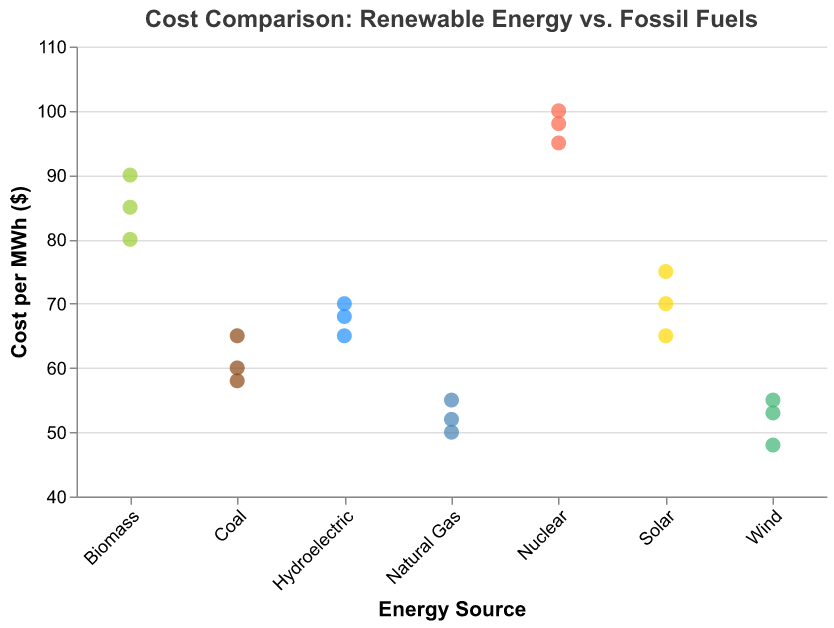What is the title of the figure? The title is displayed at the top of the figure and reads "Cost Comparison: Renewable Energy vs. Fossil Fuels."
Answer: Cost Comparison: Renewable Energy vs. Fossil Fuels Which energy source has the highest cost per MWh? By observing the data points, Nuclear has the highest costs that are around 95, 98, and 100 per MWh.
Answer: Nuclear What is the range of costs for Wind energy? The cost range for Wind energy can be determined from the minimum and maximum values of its data points. Wind energy costs are 48, 53, and 55 per MWh, so the range is from 48 to 55 per MWh.
Answer: 48 to 55 How do the costs of Natural Gas and Solar energy compare? By comparing the data points for Natural Gas (50, 52, 55) and Solar (65, 70, 75), it's clear that Solar energy generally has higher costs per MWh.
Answer: Solar has higher costs Are there any energy sources with overlapping cost ranges, and if so, which ones? To determine overlap, compare the cost ranges of all sources. Hydroelectric (65, 68, 70) and Solar (65, 70, 75) have overlapping ranges. Similarly, Natural Gas (50, 52, 55) and Wind (48, 53, 55) also overlap.
Answer: Hydroelectric and Solar, Natural Gas and Wind Which energy source has the least variation in cost per MWh? By examining the spread of data points, Natural Gas shows the least variation with costs of 50, 52, and 55 per MWh, indicating the smallest range and standard deviation.
Answer: Natural Gas What is the average cost per MWh of Solar energy? Sum the Solar energy costs (65 + 70 + 75) = 210, then divide by the number of points (3) to get the average: 210 / 3 = 70 per MWh.
Answer: 70 Which energy source has data points with the smallest cost per MWh? By inspecting the lowest data points of each source, Wind has the smallest with a point at 48 per MWh.
Answer: Wind How many data points are there in total for all energy sources? Count all the data points from each energy source: Coal (3), Natural Gas (3), Nuclear (3), Solar (3), Wind (3), Hydroelectric (3), Biomass (3), making a total of 3 + 3 + 3 + 3 + 3 + 3 + 3 = 21 data points.
Answer: 21 Which energy source has the most diverse cost values (largest range)? By comparing the cost ranges, Nuclear has values from 95 to 100, giving the largest range of 5 (100 - 95).
Answer: Nuclear 